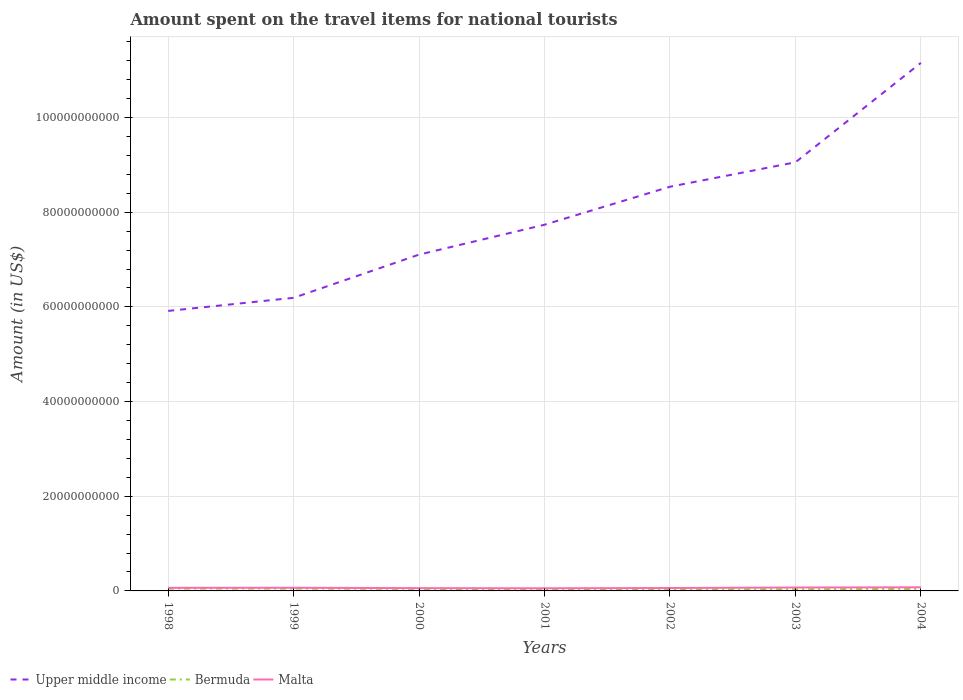How many different coloured lines are there?
Offer a very short reply. 3. Does the line corresponding to Bermuda intersect with the line corresponding to Malta?
Your response must be concise. No. Across all years, what is the maximum amount spent on the travel items for national tourists in Upper middle income?
Offer a very short reply. 5.91e+1. In which year was the amount spent on the travel items for national tourists in Upper middle income maximum?
Provide a succinct answer. 1998. What is the total amount spent on the travel items for national tourists in Upper middle income in the graph?
Your answer should be compact. -2.62e+1. What is the difference between the highest and the second highest amount spent on the travel items for national tourists in Malta?
Offer a very short reply. 2.06e+08. What is the difference between the highest and the lowest amount spent on the travel items for national tourists in Upper middle income?
Your answer should be very brief. 3. How many lines are there?
Keep it short and to the point. 3. Does the graph contain any zero values?
Provide a short and direct response. No. How many legend labels are there?
Offer a terse response. 3. What is the title of the graph?
Your answer should be very brief. Amount spent on the travel items for national tourists. Does "Paraguay" appear as one of the legend labels in the graph?
Offer a terse response. No. What is the Amount (in US$) in Upper middle income in 1998?
Give a very brief answer. 5.91e+1. What is the Amount (in US$) of Bermuda in 1998?
Make the answer very short. 4.87e+08. What is the Amount (in US$) in Malta in 1998?
Offer a terse response. 6.53e+08. What is the Amount (in US$) of Upper middle income in 1999?
Offer a very short reply. 6.19e+1. What is the Amount (in US$) in Bermuda in 1999?
Your response must be concise. 4.79e+08. What is the Amount (in US$) of Malta in 1999?
Make the answer very short. 6.67e+08. What is the Amount (in US$) of Upper middle income in 2000?
Your response must be concise. 7.10e+1. What is the Amount (in US$) in Bermuda in 2000?
Offer a terse response. 4.31e+08. What is the Amount (in US$) of Malta in 2000?
Make the answer very short. 5.87e+08. What is the Amount (in US$) in Upper middle income in 2001?
Keep it short and to the point. 7.74e+1. What is the Amount (in US$) of Bermuda in 2001?
Your answer should be compact. 3.51e+08. What is the Amount (in US$) of Malta in 2001?
Your response must be concise. 5.61e+08. What is the Amount (in US$) of Upper middle income in 2002?
Ensure brevity in your answer.  8.54e+1. What is the Amount (in US$) in Bermuda in 2002?
Keep it short and to the point. 3.78e+08. What is the Amount (in US$) in Malta in 2002?
Give a very brief answer. 6.14e+08. What is the Amount (in US$) of Upper middle income in 2003?
Your answer should be compact. 9.05e+1. What is the Amount (in US$) of Bermuda in 2003?
Give a very brief answer. 3.48e+08. What is the Amount (in US$) in Malta in 2003?
Your response must be concise. 7.22e+08. What is the Amount (in US$) of Upper middle income in 2004?
Offer a very short reply. 1.12e+11. What is the Amount (in US$) of Bermuda in 2004?
Give a very brief answer. 4.26e+08. What is the Amount (in US$) of Malta in 2004?
Ensure brevity in your answer.  7.67e+08. Across all years, what is the maximum Amount (in US$) of Upper middle income?
Make the answer very short. 1.12e+11. Across all years, what is the maximum Amount (in US$) in Bermuda?
Your answer should be very brief. 4.87e+08. Across all years, what is the maximum Amount (in US$) of Malta?
Offer a terse response. 7.67e+08. Across all years, what is the minimum Amount (in US$) in Upper middle income?
Offer a terse response. 5.91e+1. Across all years, what is the minimum Amount (in US$) in Bermuda?
Offer a very short reply. 3.48e+08. Across all years, what is the minimum Amount (in US$) of Malta?
Provide a short and direct response. 5.61e+08. What is the total Amount (in US$) of Upper middle income in the graph?
Ensure brevity in your answer.  5.57e+11. What is the total Amount (in US$) of Bermuda in the graph?
Keep it short and to the point. 2.90e+09. What is the total Amount (in US$) in Malta in the graph?
Give a very brief answer. 4.57e+09. What is the difference between the Amount (in US$) of Upper middle income in 1998 and that in 1999?
Give a very brief answer. -2.77e+09. What is the difference between the Amount (in US$) in Malta in 1998 and that in 1999?
Provide a succinct answer. -1.40e+07. What is the difference between the Amount (in US$) of Upper middle income in 1998 and that in 2000?
Give a very brief answer. -1.19e+1. What is the difference between the Amount (in US$) of Bermuda in 1998 and that in 2000?
Your response must be concise. 5.60e+07. What is the difference between the Amount (in US$) of Malta in 1998 and that in 2000?
Your answer should be compact. 6.60e+07. What is the difference between the Amount (in US$) in Upper middle income in 1998 and that in 2001?
Provide a short and direct response. -1.82e+1. What is the difference between the Amount (in US$) of Bermuda in 1998 and that in 2001?
Your answer should be very brief. 1.36e+08. What is the difference between the Amount (in US$) in Malta in 1998 and that in 2001?
Provide a succinct answer. 9.20e+07. What is the difference between the Amount (in US$) in Upper middle income in 1998 and that in 2002?
Your response must be concise. -2.62e+1. What is the difference between the Amount (in US$) in Bermuda in 1998 and that in 2002?
Give a very brief answer. 1.09e+08. What is the difference between the Amount (in US$) in Malta in 1998 and that in 2002?
Provide a succinct answer. 3.90e+07. What is the difference between the Amount (in US$) in Upper middle income in 1998 and that in 2003?
Make the answer very short. -3.14e+1. What is the difference between the Amount (in US$) of Bermuda in 1998 and that in 2003?
Provide a short and direct response. 1.39e+08. What is the difference between the Amount (in US$) in Malta in 1998 and that in 2003?
Provide a short and direct response. -6.90e+07. What is the difference between the Amount (in US$) of Upper middle income in 1998 and that in 2004?
Your answer should be very brief. -5.24e+1. What is the difference between the Amount (in US$) in Bermuda in 1998 and that in 2004?
Offer a very short reply. 6.10e+07. What is the difference between the Amount (in US$) of Malta in 1998 and that in 2004?
Your answer should be very brief. -1.14e+08. What is the difference between the Amount (in US$) in Upper middle income in 1999 and that in 2000?
Your answer should be very brief. -9.13e+09. What is the difference between the Amount (in US$) in Bermuda in 1999 and that in 2000?
Your response must be concise. 4.80e+07. What is the difference between the Amount (in US$) of Malta in 1999 and that in 2000?
Your answer should be compact. 8.00e+07. What is the difference between the Amount (in US$) of Upper middle income in 1999 and that in 2001?
Your answer should be compact. -1.54e+1. What is the difference between the Amount (in US$) in Bermuda in 1999 and that in 2001?
Your answer should be compact. 1.28e+08. What is the difference between the Amount (in US$) of Malta in 1999 and that in 2001?
Ensure brevity in your answer.  1.06e+08. What is the difference between the Amount (in US$) in Upper middle income in 1999 and that in 2002?
Make the answer very short. -2.35e+1. What is the difference between the Amount (in US$) in Bermuda in 1999 and that in 2002?
Ensure brevity in your answer.  1.01e+08. What is the difference between the Amount (in US$) in Malta in 1999 and that in 2002?
Give a very brief answer. 5.30e+07. What is the difference between the Amount (in US$) in Upper middle income in 1999 and that in 2003?
Your response must be concise. -2.86e+1. What is the difference between the Amount (in US$) in Bermuda in 1999 and that in 2003?
Your answer should be very brief. 1.31e+08. What is the difference between the Amount (in US$) in Malta in 1999 and that in 2003?
Ensure brevity in your answer.  -5.50e+07. What is the difference between the Amount (in US$) in Upper middle income in 1999 and that in 2004?
Offer a very short reply. -4.96e+1. What is the difference between the Amount (in US$) of Bermuda in 1999 and that in 2004?
Ensure brevity in your answer.  5.30e+07. What is the difference between the Amount (in US$) of Malta in 1999 and that in 2004?
Make the answer very short. -1.00e+08. What is the difference between the Amount (in US$) of Upper middle income in 2000 and that in 2001?
Your answer should be compact. -6.31e+09. What is the difference between the Amount (in US$) of Bermuda in 2000 and that in 2001?
Your answer should be very brief. 8.00e+07. What is the difference between the Amount (in US$) in Malta in 2000 and that in 2001?
Provide a succinct answer. 2.60e+07. What is the difference between the Amount (in US$) in Upper middle income in 2000 and that in 2002?
Ensure brevity in your answer.  -1.43e+1. What is the difference between the Amount (in US$) of Bermuda in 2000 and that in 2002?
Provide a short and direct response. 5.30e+07. What is the difference between the Amount (in US$) in Malta in 2000 and that in 2002?
Keep it short and to the point. -2.70e+07. What is the difference between the Amount (in US$) of Upper middle income in 2000 and that in 2003?
Provide a succinct answer. -1.95e+1. What is the difference between the Amount (in US$) of Bermuda in 2000 and that in 2003?
Provide a succinct answer. 8.30e+07. What is the difference between the Amount (in US$) in Malta in 2000 and that in 2003?
Offer a very short reply. -1.35e+08. What is the difference between the Amount (in US$) in Upper middle income in 2000 and that in 2004?
Provide a short and direct response. -4.05e+1. What is the difference between the Amount (in US$) of Bermuda in 2000 and that in 2004?
Give a very brief answer. 5.00e+06. What is the difference between the Amount (in US$) of Malta in 2000 and that in 2004?
Provide a short and direct response. -1.80e+08. What is the difference between the Amount (in US$) of Upper middle income in 2001 and that in 2002?
Ensure brevity in your answer.  -8.03e+09. What is the difference between the Amount (in US$) in Bermuda in 2001 and that in 2002?
Provide a short and direct response. -2.70e+07. What is the difference between the Amount (in US$) of Malta in 2001 and that in 2002?
Provide a succinct answer. -5.30e+07. What is the difference between the Amount (in US$) of Upper middle income in 2001 and that in 2003?
Provide a succinct answer. -1.32e+1. What is the difference between the Amount (in US$) in Malta in 2001 and that in 2003?
Provide a succinct answer. -1.61e+08. What is the difference between the Amount (in US$) of Upper middle income in 2001 and that in 2004?
Make the answer very short. -3.42e+1. What is the difference between the Amount (in US$) of Bermuda in 2001 and that in 2004?
Your response must be concise. -7.50e+07. What is the difference between the Amount (in US$) of Malta in 2001 and that in 2004?
Provide a succinct answer. -2.06e+08. What is the difference between the Amount (in US$) in Upper middle income in 2002 and that in 2003?
Make the answer very short. -5.16e+09. What is the difference between the Amount (in US$) in Bermuda in 2002 and that in 2003?
Offer a terse response. 3.00e+07. What is the difference between the Amount (in US$) in Malta in 2002 and that in 2003?
Your answer should be very brief. -1.08e+08. What is the difference between the Amount (in US$) in Upper middle income in 2002 and that in 2004?
Your answer should be very brief. -2.62e+1. What is the difference between the Amount (in US$) of Bermuda in 2002 and that in 2004?
Your answer should be compact. -4.80e+07. What is the difference between the Amount (in US$) of Malta in 2002 and that in 2004?
Ensure brevity in your answer.  -1.53e+08. What is the difference between the Amount (in US$) in Upper middle income in 2003 and that in 2004?
Keep it short and to the point. -2.10e+1. What is the difference between the Amount (in US$) in Bermuda in 2003 and that in 2004?
Ensure brevity in your answer.  -7.80e+07. What is the difference between the Amount (in US$) in Malta in 2003 and that in 2004?
Offer a terse response. -4.50e+07. What is the difference between the Amount (in US$) in Upper middle income in 1998 and the Amount (in US$) in Bermuda in 1999?
Make the answer very short. 5.87e+1. What is the difference between the Amount (in US$) of Upper middle income in 1998 and the Amount (in US$) of Malta in 1999?
Your response must be concise. 5.85e+1. What is the difference between the Amount (in US$) in Bermuda in 1998 and the Amount (in US$) in Malta in 1999?
Provide a short and direct response. -1.80e+08. What is the difference between the Amount (in US$) in Upper middle income in 1998 and the Amount (in US$) in Bermuda in 2000?
Your answer should be compact. 5.87e+1. What is the difference between the Amount (in US$) of Upper middle income in 1998 and the Amount (in US$) of Malta in 2000?
Provide a short and direct response. 5.86e+1. What is the difference between the Amount (in US$) of Bermuda in 1998 and the Amount (in US$) of Malta in 2000?
Provide a succinct answer. -1.00e+08. What is the difference between the Amount (in US$) in Upper middle income in 1998 and the Amount (in US$) in Bermuda in 2001?
Offer a terse response. 5.88e+1. What is the difference between the Amount (in US$) of Upper middle income in 1998 and the Amount (in US$) of Malta in 2001?
Your answer should be very brief. 5.86e+1. What is the difference between the Amount (in US$) of Bermuda in 1998 and the Amount (in US$) of Malta in 2001?
Provide a short and direct response. -7.40e+07. What is the difference between the Amount (in US$) in Upper middle income in 1998 and the Amount (in US$) in Bermuda in 2002?
Provide a succinct answer. 5.88e+1. What is the difference between the Amount (in US$) of Upper middle income in 1998 and the Amount (in US$) of Malta in 2002?
Provide a succinct answer. 5.85e+1. What is the difference between the Amount (in US$) of Bermuda in 1998 and the Amount (in US$) of Malta in 2002?
Your answer should be compact. -1.27e+08. What is the difference between the Amount (in US$) of Upper middle income in 1998 and the Amount (in US$) of Bermuda in 2003?
Provide a succinct answer. 5.88e+1. What is the difference between the Amount (in US$) in Upper middle income in 1998 and the Amount (in US$) in Malta in 2003?
Give a very brief answer. 5.84e+1. What is the difference between the Amount (in US$) in Bermuda in 1998 and the Amount (in US$) in Malta in 2003?
Your answer should be very brief. -2.35e+08. What is the difference between the Amount (in US$) of Upper middle income in 1998 and the Amount (in US$) of Bermuda in 2004?
Ensure brevity in your answer.  5.87e+1. What is the difference between the Amount (in US$) of Upper middle income in 1998 and the Amount (in US$) of Malta in 2004?
Your response must be concise. 5.84e+1. What is the difference between the Amount (in US$) of Bermuda in 1998 and the Amount (in US$) of Malta in 2004?
Keep it short and to the point. -2.80e+08. What is the difference between the Amount (in US$) in Upper middle income in 1999 and the Amount (in US$) in Bermuda in 2000?
Offer a very short reply. 6.15e+1. What is the difference between the Amount (in US$) of Upper middle income in 1999 and the Amount (in US$) of Malta in 2000?
Your answer should be very brief. 6.13e+1. What is the difference between the Amount (in US$) in Bermuda in 1999 and the Amount (in US$) in Malta in 2000?
Give a very brief answer. -1.08e+08. What is the difference between the Amount (in US$) in Upper middle income in 1999 and the Amount (in US$) in Bermuda in 2001?
Offer a terse response. 6.16e+1. What is the difference between the Amount (in US$) in Upper middle income in 1999 and the Amount (in US$) in Malta in 2001?
Keep it short and to the point. 6.14e+1. What is the difference between the Amount (in US$) in Bermuda in 1999 and the Amount (in US$) in Malta in 2001?
Your answer should be very brief. -8.20e+07. What is the difference between the Amount (in US$) in Upper middle income in 1999 and the Amount (in US$) in Bermuda in 2002?
Your answer should be very brief. 6.15e+1. What is the difference between the Amount (in US$) in Upper middle income in 1999 and the Amount (in US$) in Malta in 2002?
Provide a short and direct response. 6.13e+1. What is the difference between the Amount (in US$) in Bermuda in 1999 and the Amount (in US$) in Malta in 2002?
Offer a very short reply. -1.35e+08. What is the difference between the Amount (in US$) in Upper middle income in 1999 and the Amount (in US$) in Bermuda in 2003?
Make the answer very short. 6.16e+1. What is the difference between the Amount (in US$) of Upper middle income in 1999 and the Amount (in US$) of Malta in 2003?
Your answer should be very brief. 6.12e+1. What is the difference between the Amount (in US$) in Bermuda in 1999 and the Amount (in US$) in Malta in 2003?
Your response must be concise. -2.43e+08. What is the difference between the Amount (in US$) of Upper middle income in 1999 and the Amount (in US$) of Bermuda in 2004?
Your answer should be compact. 6.15e+1. What is the difference between the Amount (in US$) in Upper middle income in 1999 and the Amount (in US$) in Malta in 2004?
Offer a very short reply. 6.11e+1. What is the difference between the Amount (in US$) of Bermuda in 1999 and the Amount (in US$) of Malta in 2004?
Give a very brief answer. -2.88e+08. What is the difference between the Amount (in US$) of Upper middle income in 2000 and the Amount (in US$) of Bermuda in 2001?
Provide a short and direct response. 7.07e+1. What is the difference between the Amount (in US$) of Upper middle income in 2000 and the Amount (in US$) of Malta in 2001?
Offer a very short reply. 7.05e+1. What is the difference between the Amount (in US$) of Bermuda in 2000 and the Amount (in US$) of Malta in 2001?
Make the answer very short. -1.30e+08. What is the difference between the Amount (in US$) of Upper middle income in 2000 and the Amount (in US$) of Bermuda in 2002?
Your response must be concise. 7.07e+1. What is the difference between the Amount (in US$) in Upper middle income in 2000 and the Amount (in US$) in Malta in 2002?
Your response must be concise. 7.04e+1. What is the difference between the Amount (in US$) in Bermuda in 2000 and the Amount (in US$) in Malta in 2002?
Ensure brevity in your answer.  -1.83e+08. What is the difference between the Amount (in US$) in Upper middle income in 2000 and the Amount (in US$) in Bermuda in 2003?
Offer a very short reply. 7.07e+1. What is the difference between the Amount (in US$) of Upper middle income in 2000 and the Amount (in US$) of Malta in 2003?
Make the answer very short. 7.03e+1. What is the difference between the Amount (in US$) of Bermuda in 2000 and the Amount (in US$) of Malta in 2003?
Make the answer very short. -2.91e+08. What is the difference between the Amount (in US$) of Upper middle income in 2000 and the Amount (in US$) of Bermuda in 2004?
Ensure brevity in your answer.  7.06e+1. What is the difference between the Amount (in US$) of Upper middle income in 2000 and the Amount (in US$) of Malta in 2004?
Your answer should be compact. 7.03e+1. What is the difference between the Amount (in US$) of Bermuda in 2000 and the Amount (in US$) of Malta in 2004?
Provide a short and direct response. -3.36e+08. What is the difference between the Amount (in US$) in Upper middle income in 2001 and the Amount (in US$) in Bermuda in 2002?
Your response must be concise. 7.70e+1. What is the difference between the Amount (in US$) in Upper middle income in 2001 and the Amount (in US$) in Malta in 2002?
Provide a short and direct response. 7.67e+1. What is the difference between the Amount (in US$) in Bermuda in 2001 and the Amount (in US$) in Malta in 2002?
Offer a terse response. -2.63e+08. What is the difference between the Amount (in US$) in Upper middle income in 2001 and the Amount (in US$) in Bermuda in 2003?
Your answer should be very brief. 7.70e+1. What is the difference between the Amount (in US$) in Upper middle income in 2001 and the Amount (in US$) in Malta in 2003?
Your answer should be very brief. 7.66e+1. What is the difference between the Amount (in US$) in Bermuda in 2001 and the Amount (in US$) in Malta in 2003?
Your answer should be very brief. -3.71e+08. What is the difference between the Amount (in US$) in Upper middle income in 2001 and the Amount (in US$) in Bermuda in 2004?
Provide a short and direct response. 7.69e+1. What is the difference between the Amount (in US$) of Upper middle income in 2001 and the Amount (in US$) of Malta in 2004?
Ensure brevity in your answer.  7.66e+1. What is the difference between the Amount (in US$) in Bermuda in 2001 and the Amount (in US$) in Malta in 2004?
Ensure brevity in your answer.  -4.16e+08. What is the difference between the Amount (in US$) of Upper middle income in 2002 and the Amount (in US$) of Bermuda in 2003?
Provide a succinct answer. 8.50e+1. What is the difference between the Amount (in US$) of Upper middle income in 2002 and the Amount (in US$) of Malta in 2003?
Ensure brevity in your answer.  8.47e+1. What is the difference between the Amount (in US$) in Bermuda in 2002 and the Amount (in US$) in Malta in 2003?
Your answer should be very brief. -3.44e+08. What is the difference between the Amount (in US$) of Upper middle income in 2002 and the Amount (in US$) of Bermuda in 2004?
Your answer should be compact. 8.50e+1. What is the difference between the Amount (in US$) in Upper middle income in 2002 and the Amount (in US$) in Malta in 2004?
Ensure brevity in your answer.  8.46e+1. What is the difference between the Amount (in US$) in Bermuda in 2002 and the Amount (in US$) in Malta in 2004?
Provide a short and direct response. -3.89e+08. What is the difference between the Amount (in US$) in Upper middle income in 2003 and the Amount (in US$) in Bermuda in 2004?
Offer a terse response. 9.01e+1. What is the difference between the Amount (in US$) of Upper middle income in 2003 and the Amount (in US$) of Malta in 2004?
Give a very brief answer. 8.98e+1. What is the difference between the Amount (in US$) in Bermuda in 2003 and the Amount (in US$) in Malta in 2004?
Make the answer very short. -4.19e+08. What is the average Amount (in US$) of Upper middle income per year?
Provide a short and direct response. 7.96e+1. What is the average Amount (in US$) in Bermuda per year?
Give a very brief answer. 4.14e+08. What is the average Amount (in US$) in Malta per year?
Offer a terse response. 6.53e+08. In the year 1998, what is the difference between the Amount (in US$) in Upper middle income and Amount (in US$) in Bermuda?
Make the answer very short. 5.87e+1. In the year 1998, what is the difference between the Amount (in US$) of Upper middle income and Amount (in US$) of Malta?
Provide a short and direct response. 5.85e+1. In the year 1998, what is the difference between the Amount (in US$) in Bermuda and Amount (in US$) in Malta?
Your answer should be very brief. -1.66e+08. In the year 1999, what is the difference between the Amount (in US$) in Upper middle income and Amount (in US$) in Bermuda?
Provide a short and direct response. 6.14e+1. In the year 1999, what is the difference between the Amount (in US$) of Upper middle income and Amount (in US$) of Malta?
Give a very brief answer. 6.12e+1. In the year 1999, what is the difference between the Amount (in US$) in Bermuda and Amount (in US$) in Malta?
Your answer should be compact. -1.88e+08. In the year 2000, what is the difference between the Amount (in US$) in Upper middle income and Amount (in US$) in Bermuda?
Provide a short and direct response. 7.06e+1. In the year 2000, what is the difference between the Amount (in US$) of Upper middle income and Amount (in US$) of Malta?
Keep it short and to the point. 7.05e+1. In the year 2000, what is the difference between the Amount (in US$) of Bermuda and Amount (in US$) of Malta?
Provide a short and direct response. -1.56e+08. In the year 2001, what is the difference between the Amount (in US$) in Upper middle income and Amount (in US$) in Bermuda?
Provide a succinct answer. 7.70e+1. In the year 2001, what is the difference between the Amount (in US$) in Upper middle income and Amount (in US$) in Malta?
Offer a very short reply. 7.68e+1. In the year 2001, what is the difference between the Amount (in US$) of Bermuda and Amount (in US$) of Malta?
Provide a short and direct response. -2.10e+08. In the year 2002, what is the difference between the Amount (in US$) of Upper middle income and Amount (in US$) of Bermuda?
Ensure brevity in your answer.  8.50e+1. In the year 2002, what is the difference between the Amount (in US$) of Upper middle income and Amount (in US$) of Malta?
Offer a terse response. 8.48e+1. In the year 2002, what is the difference between the Amount (in US$) of Bermuda and Amount (in US$) of Malta?
Make the answer very short. -2.36e+08. In the year 2003, what is the difference between the Amount (in US$) in Upper middle income and Amount (in US$) in Bermuda?
Provide a succinct answer. 9.02e+1. In the year 2003, what is the difference between the Amount (in US$) of Upper middle income and Amount (in US$) of Malta?
Provide a short and direct response. 8.98e+1. In the year 2003, what is the difference between the Amount (in US$) of Bermuda and Amount (in US$) of Malta?
Your answer should be very brief. -3.74e+08. In the year 2004, what is the difference between the Amount (in US$) of Upper middle income and Amount (in US$) of Bermuda?
Keep it short and to the point. 1.11e+11. In the year 2004, what is the difference between the Amount (in US$) of Upper middle income and Amount (in US$) of Malta?
Your answer should be very brief. 1.11e+11. In the year 2004, what is the difference between the Amount (in US$) of Bermuda and Amount (in US$) of Malta?
Your answer should be compact. -3.41e+08. What is the ratio of the Amount (in US$) of Upper middle income in 1998 to that in 1999?
Your answer should be compact. 0.96. What is the ratio of the Amount (in US$) of Bermuda in 1998 to that in 1999?
Your answer should be compact. 1.02. What is the ratio of the Amount (in US$) of Upper middle income in 1998 to that in 2000?
Offer a very short reply. 0.83. What is the ratio of the Amount (in US$) of Bermuda in 1998 to that in 2000?
Keep it short and to the point. 1.13. What is the ratio of the Amount (in US$) in Malta in 1998 to that in 2000?
Offer a very short reply. 1.11. What is the ratio of the Amount (in US$) of Upper middle income in 1998 to that in 2001?
Make the answer very short. 0.76. What is the ratio of the Amount (in US$) of Bermuda in 1998 to that in 2001?
Offer a terse response. 1.39. What is the ratio of the Amount (in US$) of Malta in 1998 to that in 2001?
Your response must be concise. 1.16. What is the ratio of the Amount (in US$) of Upper middle income in 1998 to that in 2002?
Offer a very short reply. 0.69. What is the ratio of the Amount (in US$) of Bermuda in 1998 to that in 2002?
Provide a succinct answer. 1.29. What is the ratio of the Amount (in US$) in Malta in 1998 to that in 2002?
Your answer should be very brief. 1.06. What is the ratio of the Amount (in US$) in Upper middle income in 1998 to that in 2003?
Make the answer very short. 0.65. What is the ratio of the Amount (in US$) in Bermuda in 1998 to that in 2003?
Ensure brevity in your answer.  1.4. What is the ratio of the Amount (in US$) of Malta in 1998 to that in 2003?
Offer a terse response. 0.9. What is the ratio of the Amount (in US$) of Upper middle income in 1998 to that in 2004?
Offer a very short reply. 0.53. What is the ratio of the Amount (in US$) in Bermuda in 1998 to that in 2004?
Your response must be concise. 1.14. What is the ratio of the Amount (in US$) in Malta in 1998 to that in 2004?
Your answer should be compact. 0.85. What is the ratio of the Amount (in US$) in Upper middle income in 1999 to that in 2000?
Your answer should be very brief. 0.87. What is the ratio of the Amount (in US$) in Bermuda in 1999 to that in 2000?
Your response must be concise. 1.11. What is the ratio of the Amount (in US$) in Malta in 1999 to that in 2000?
Your answer should be very brief. 1.14. What is the ratio of the Amount (in US$) of Upper middle income in 1999 to that in 2001?
Keep it short and to the point. 0.8. What is the ratio of the Amount (in US$) in Bermuda in 1999 to that in 2001?
Your answer should be very brief. 1.36. What is the ratio of the Amount (in US$) in Malta in 1999 to that in 2001?
Ensure brevity in your answer.  1.19. What is the ratio of the Amount (in US$) in Upper middle income in 1999 to that in 2002?
Make the answer very short. 0.73. What is the ratio of the Amount (in US$) in Bermuda in 1999 to that in 2002?
Keep it short and to the point. 1.27. What is the ratio of the Amount (in US$) of Malta in 1999 to that in 2002?
Make the answer very short. 1.09. What is the ratio of the Amount (in US$) of Upper middle income in 1999 to that in 2003?
Ensure brevity in your answer.  0.68. What is the ratio of the Amount (in US$) in Bermuda in 1999 to that in 2003?
Provide a short and direct response. 1.38. What is the ratio of the Amount (in US$) of Malta in 1999 to that in 2003?
Give a very brief answer. 0.92. What is the ratio of the Amount (in US$) in Upper middle income in 1999 to that in 2004?
Offer a terse response. 0.56. What is the ratio of the Amount (in US$) of Bermuda in 1999 to that in 2004?
Your answer should be very brief. 1.12. What is the ratio of the Amount (in US$) of Malta in 1999 to that in 2004?
Provide a short and direct response. 0.87. What is the ratio of the Amount (in US$) of Upper middle income in 2000 to that in 2001?
Ensure brevity in your answer.  0.92. What is the ratio of the Amount (in US$) of Bermuda in 2000 to that in 2001?
Ensure brevity in your answer.  1.23. What is the ratio of the Amount (in US$) of Malta in 2000 to that in 2001?
Give a very brief answer. 1.05. What is the ratio of the Amount (in US$) of Upper middle income in 2000 to that in 2002?
Give a very brief answer. 0.83. What is the ratio of the Amount (in US$) in Bermuda in 2000 to that in 2002?
Offer a very short reply. 1.14. What is the ratio of the Amount (in US$) of Malta in 2000 to that in 2002?
Give a very brief answer. 0.96. What is the ratio of the Amount (in US$) in Upper middle income in 2000 to that in 2003?
Offer a very short reply. 0.78. What is the ratio of the Amount (in US$) of Bermuda in 2000 to that in 2003?
Offer a very short reply. 1.24. What is the ratio of the Amount (in US$) in Malta in 2000 to that in 2003?
Provide a succinct answer. 0.81. What is the ratio of the Amount (in US$) in Upper middle income in 2000 to that in 2004?
Your response must be concise. 0.64. What is the ratio of the Amount (in US$) in Bermuda in 2000 to that in 2004?
Your answer should be compact. 1.01. What is the ratio of the Amount (in US$) of Malta in 2000 to that in 2004?
Your answer should be very brief. 0.77. What is the ratio of the Amount (in US$) of Upper middle income in 2001 to that in 2002?
Provide a short and direct response. 0.91. What is the ratio of the Amount (in US$) in Bermuda in 2001 to that in 2002?
Make the answer very short. 0.93. What is the ratio of the Amount (in US$) in Malta in 2001 to that in 2002?
Offer a very short reply. 0.91. What is the ratio of the Amount (in US$) of Upper middle income in 2001 to that in 2003?
Give a very brief answer. 0.85. What is the ratio of the Amount (in US$) in Bermuda in 2001 to that in 2003?
Offer a terse response. 1.01. What is the ratio of the Amount (in US$) of Malta in 2001 to that in 2003?
Provide a short and direct response. 0.78. What is the ratio of the Amount (in US$) in Upper middle income in 2001 to that in 2004?
Your answer should be very brief. 0.69. What is the ratio of the Amount (in US$) in Bermuda in 2001 to that in 2004?
Your answer should be very brief. 0.82. What is the ratio of the Amount (in US$) in Malta in 2001 to that in 2004?
Your response must be concise. 0.73. What is the ratio of the Amount (in US$) in Upper middle income in 2002 to that in 2003?
Ensure brevity in your answer.  0.94. What is the ratio of the Amount (in US$) of Bermuda in 2002 to that in 2003?
Your answer should be very brief. 1.09. What is the ratio of the Amount (in US$) of Malta in 2002 to that in 2003?
Your answer should be very brief. 0.85. What is the ratio of the Amount (in US$) of Upper middle income in 2002 to that in 2004?
Your response must be concise. 0.77. What is the ratio of the Amount (in US$) in Bermuda in 2002 to that in 2004?
Provide a succinct answer. 0.89. What is the ratio of the Amount (in US$) in Malta in 2002 to that in 2004?
Ensure brevity in your answer.  0.8. What is the ratio of the Amount (in US$) in Upper middle income in 2003 to that in 2004?
Your answer should be very brief. 0.81. What is the ratio of the Amount (in US$) of Bermuda in 2003 to that in 2004?
Your answer should be very brief. 0.82. What is the ratio of the Amount (in US$) in Malta in 2003 to that in 2004?
Your answer should be compact. 0.94. What is the difference between the highest and the second highest Amount (in US$) of Upper middle income?
Provide a succinct answer. 2.10e+1. What is the difference between the highest and the second highest Amount (in US$) of Bermuda?
Provide a short and direct response. 8.00e+06. What is the difference between the highest and the second highest Amount (in US$) of Malta?
Offer a very short reply. 4.50e+07. What is the difference between the highest and the lowest Amount (in US$) of Upper middle income?
Offer a terse response. 5.24e+1. What is the difference between the highest and the lowest Amount (in US$) in Bermuda?
Provide a succinct answer. 1.39e+08. What is the difference between the highest and the lowest Amount (in US$) of Malta?
Ensure brevity in your answer.  2.06e+08. 